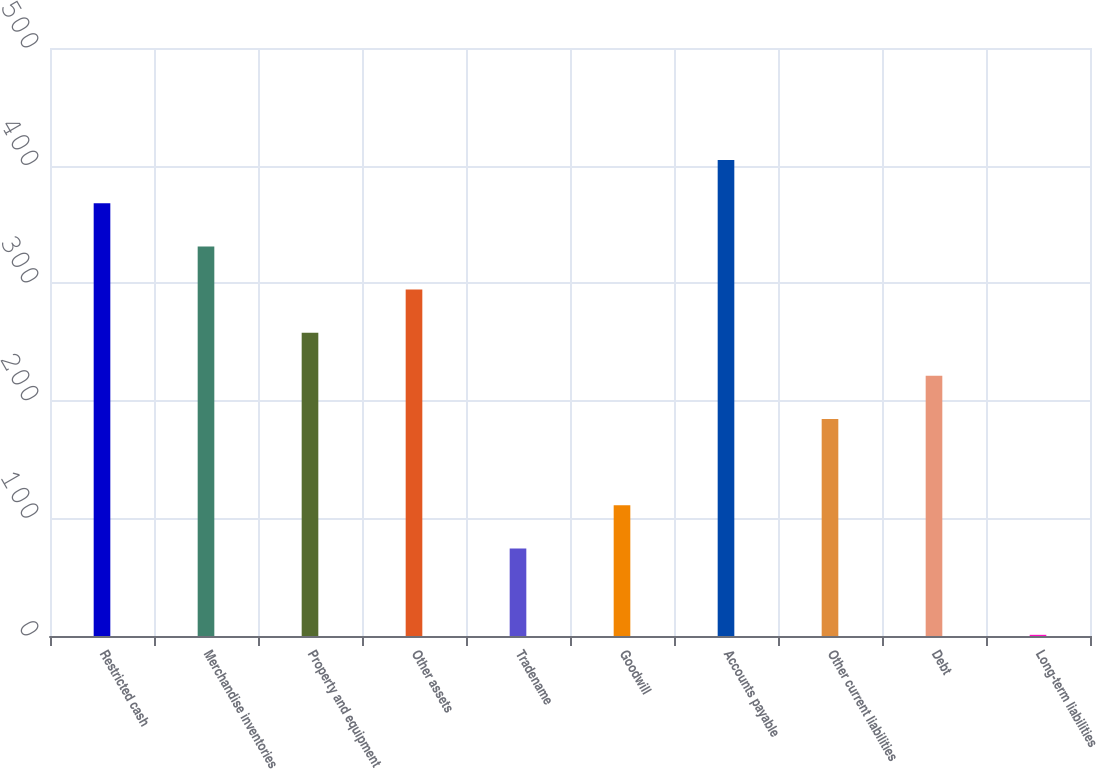Convert chart to OTSL. <chart><loc_0><loc_0><loc_500><loc_500><bar_chart><fcel>Restricted cash<fcel>Merchandise inventories<fcel>Property and equipment<fcel>Other assets<fcel>Tradename<fcel>Goodwill<fcel>Accounts payable<fcel>Other current liabilities<fcel>Debt<fcel>Long-term liabilities<nl><fcel>368<fcel>331.3<fcel>257.9<fcel>294.6<fcel>74.4<fcel>111.1<fcel>404.7<fcel>184.5<fcel>221.2<fcel>1<nl></chart> 